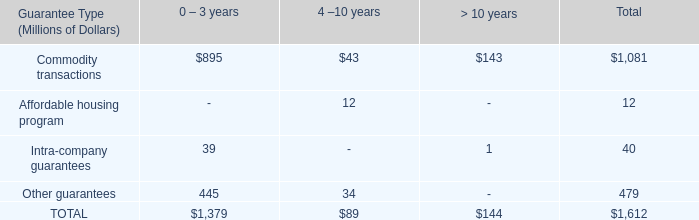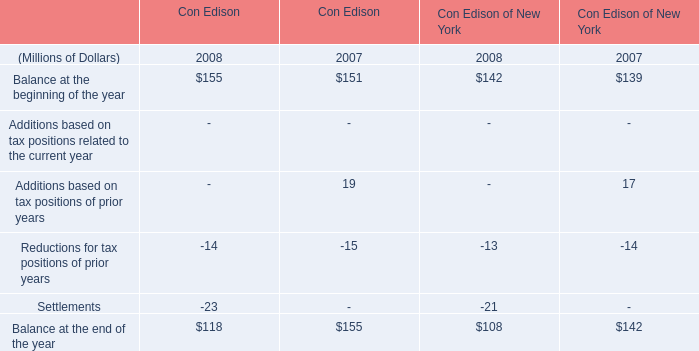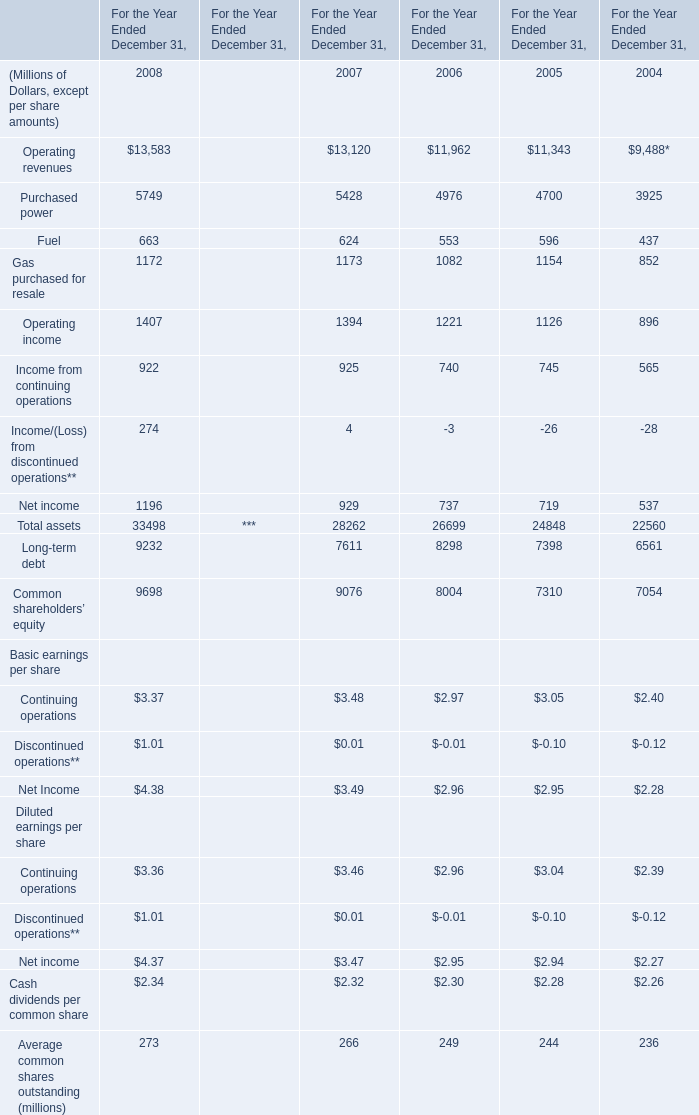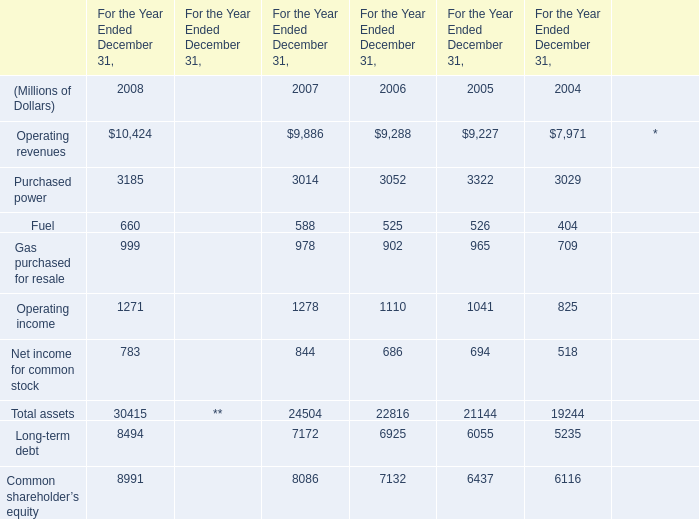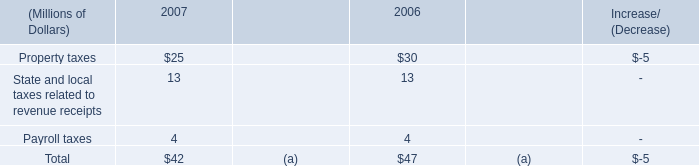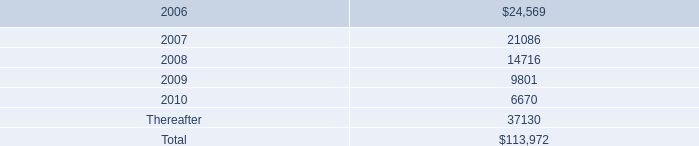Does the value of Operating income in 2008 greater than that in 2007? 
Answer: no. 